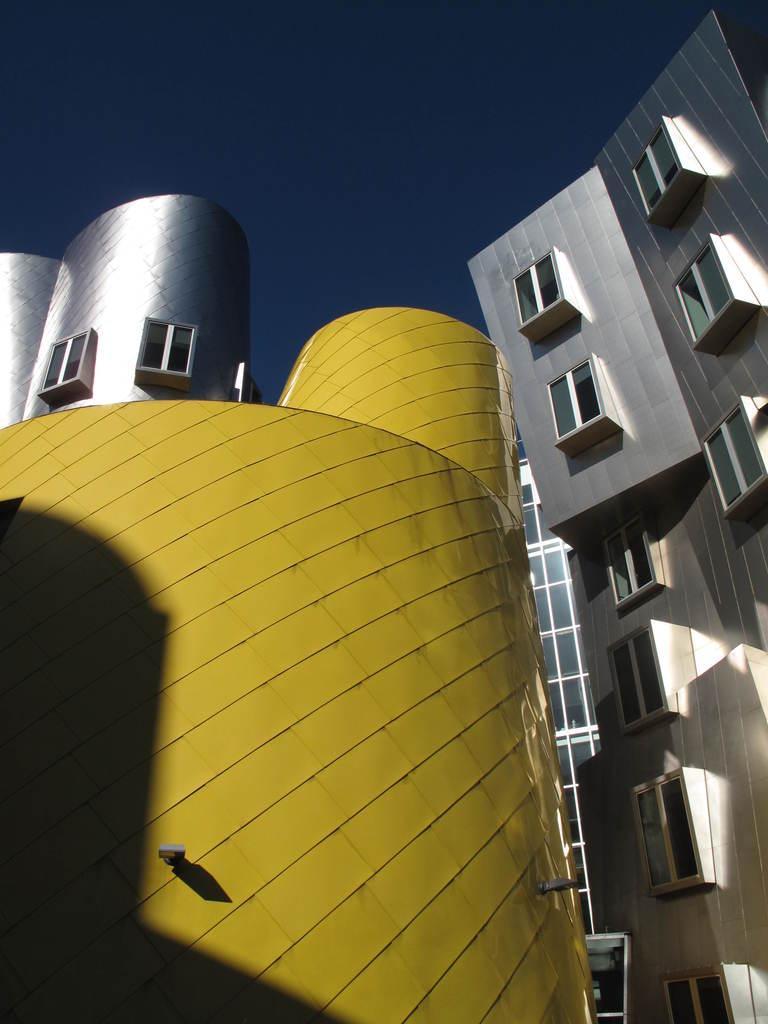Describe this image in one or two sentences. In the middle of the image we can see some buildings. At the top of the image we can see the sky. 